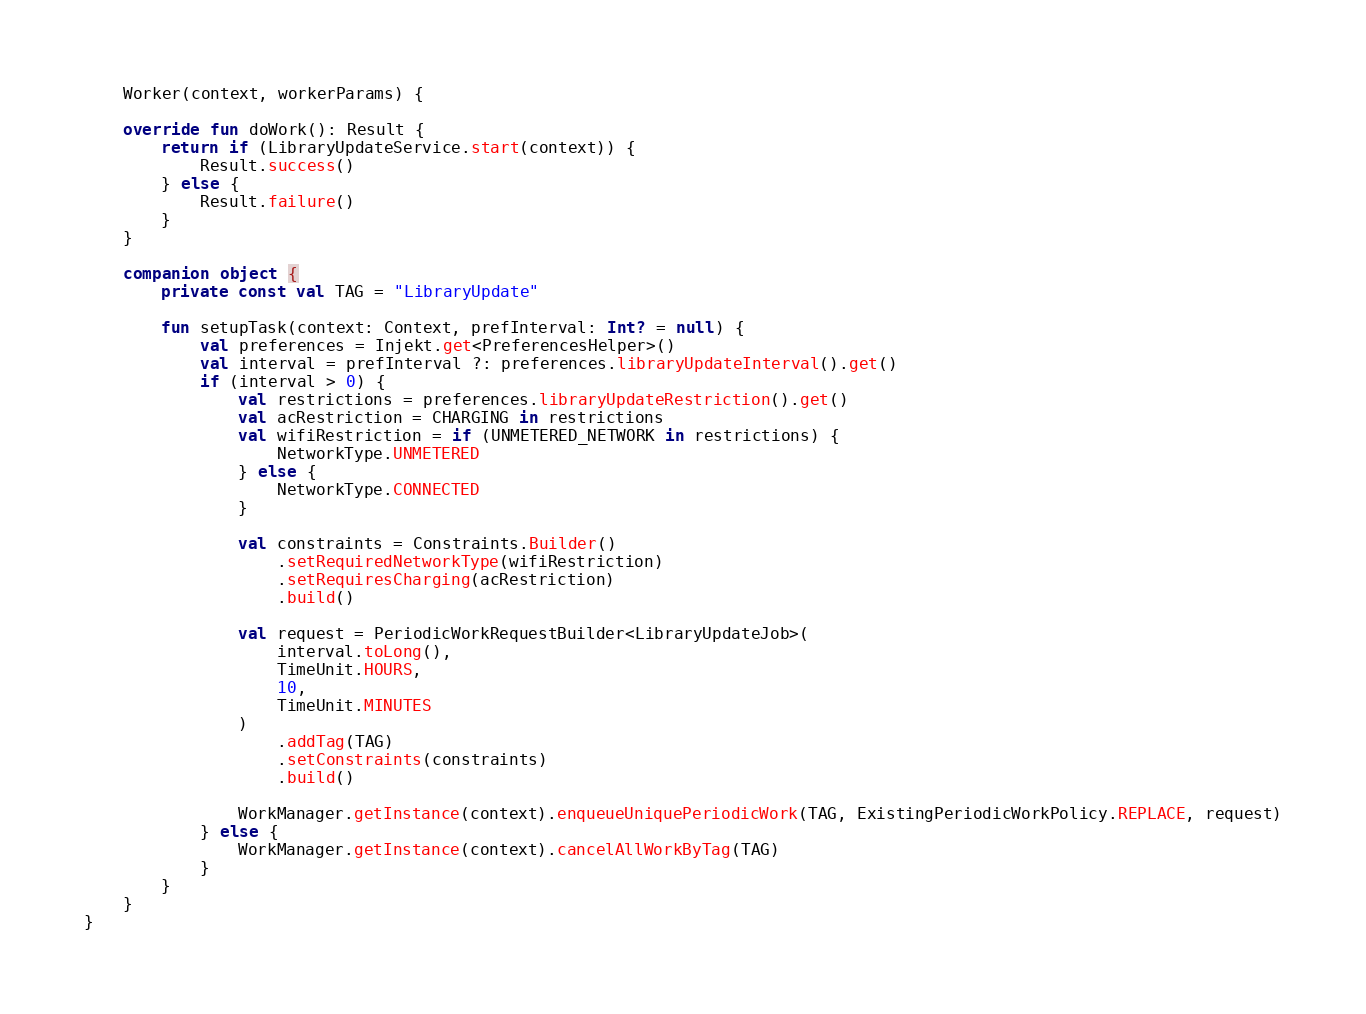Convert code to text. <code><loc_0><loc_0><loc_500><loc_500><_Kotlin_>    Worker(context, workerParams) {

    override fun doWork(): Result {
        return if (LibraryUpdateService.start(context)) {
            Result.success()
        } else {
            Result.failure()
        }
    }

    companion object {
        private const val TAG = "LibraryUpdate"

        fun setupTask(context: Context, prefInterval: Int? = null) {
            val preferences = Injekt.get<PreferencesHelper>()
            val interval = prefInterval ?: preferences.libraryUpdateInterval().get()
            if (interval > 0) {
                val restrictions = preferences.libraryUpdateRestriction().get()
                val acRestriction = CHARGING in restrictions
                val wifiRestriction = if (UNMETERED_NETWORK in restrictions) {
                    NetworkType.UNMETERED
                } else {
                    NetworkType.CONNECTED
                }

                val constraints = Constraints.Builder()
                    .setRequiredNetworkType(wifiRestriction)
                    .setRequiresCharging(acRestriction)
                    .build()

                val request = PeriodicWorkRequestBuilder<LibraryUpdateJob>(
                    interval.toLong(),
                    TimeUnit.HOURS,
                    10,
                    TimeUnit.MINUTES
                )
                    .addTag(TAG)
                    .setConstraints(constraints)
                    .build()

                WorkManager.getInstance(context).enqueueUniquePeriodicWork(TAG, ExistingPeriodicWorkPolicy.REPLACE, request)
            } else {
                WorkManager.getInstance(context).cancelAllWorkByTag(TAG)
            }
        }
    }
}
</code> 